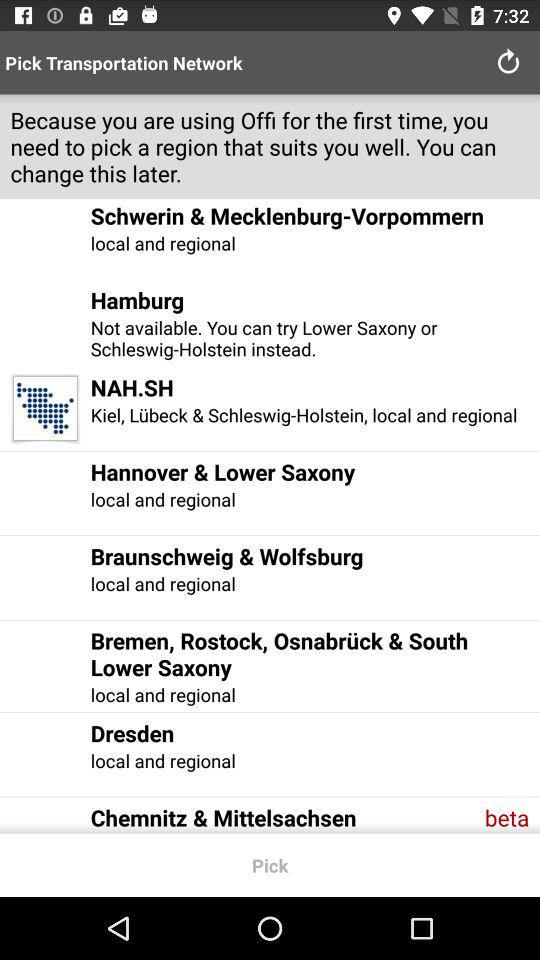How many regions are available for selection?
Answer the question using a single word or phrase. 8 